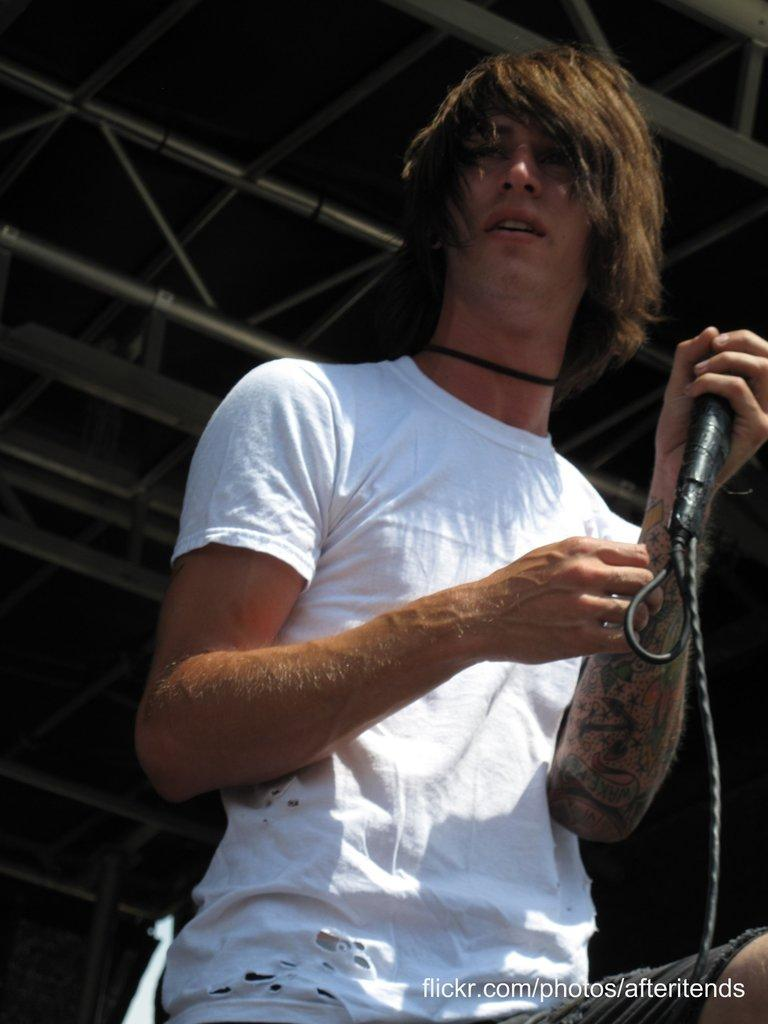What is the main subject of the image? There is a man in the image. What is the man holding in his left hand? The man is holding a microphone in his left hand. Who is the man looking at? The man is looking at someone else. What is the weather like in the image? The provided facts do not mention anything about the weather, so it cannot be determined from the image. How does the air affect the man's head in the image? There is no information about the air or its effect on the man's head in the image. 